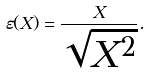<formula> <loc_0><loc_0><loc_500><loc_500>\varepsilon ( X ) = \frac { X } { \sqrt { X ^ { 2 } } } .</formula> 